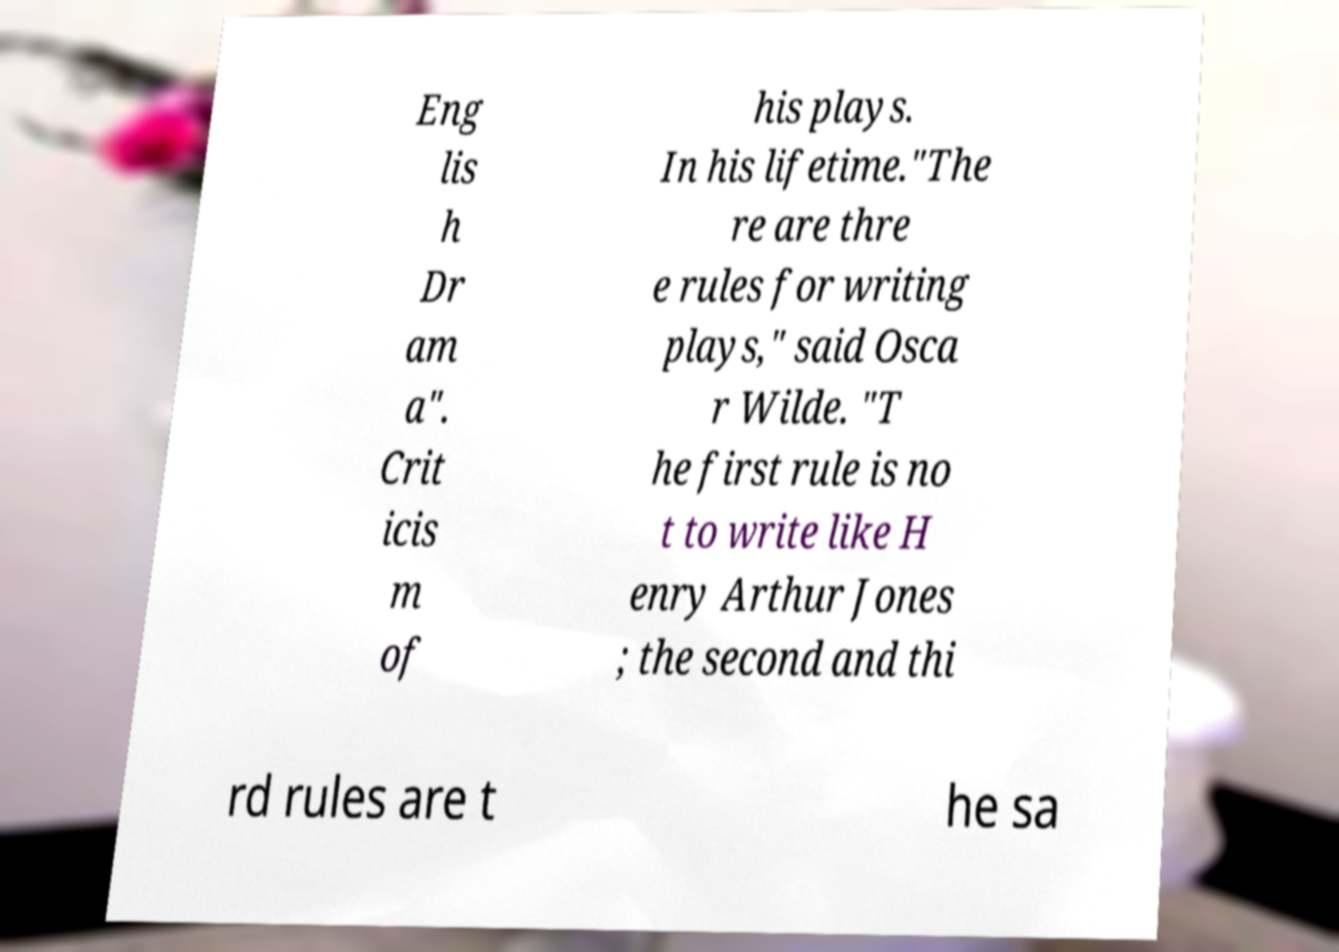Can you read and provide the text displayed in the image?This photo seems to have some interesting text. Can you extract and type it out for me? Eng lis h Dr am a". Crit icis m of his plays. In his lifetime."The re are thre e rules for writing plays," said Osca r Wilde. "T he first rule is no t to write like H enry Arthur Jones ; the second and thi rd rules are t he sa 